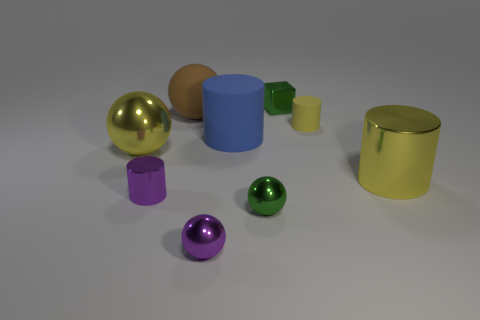Subtract all small green shiny spheres. How many spheres are left? 3 Subtract all purple spheres. How many spheres are left? 3 Subtract 2 cylinders. How many cylinders are left? 2 Add 1 small purple shiny things. How many objects exist? 10 Subtract all blue spheres. Subtract all gray cylinders. How many spheres are left? 4 Subtract all spheres. How many objects are left? 5 Subtract all large green rubber cylinders. Subtract all green cubes. How many objects are left? 8 Add 4 large yellow metallic things. How many large yellow metallic things are left? 6 Add 2 purple objects. How many purple objects exist? 4 Subtract 0 cyan cylinders. How many objects are left? 9 